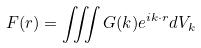<formula> <loc_0><loc_0><loc_500><loc_500>F ( r ) = \iiint G ( k ) e ^ { i k \cdot r } d V _ { k }</formula> 